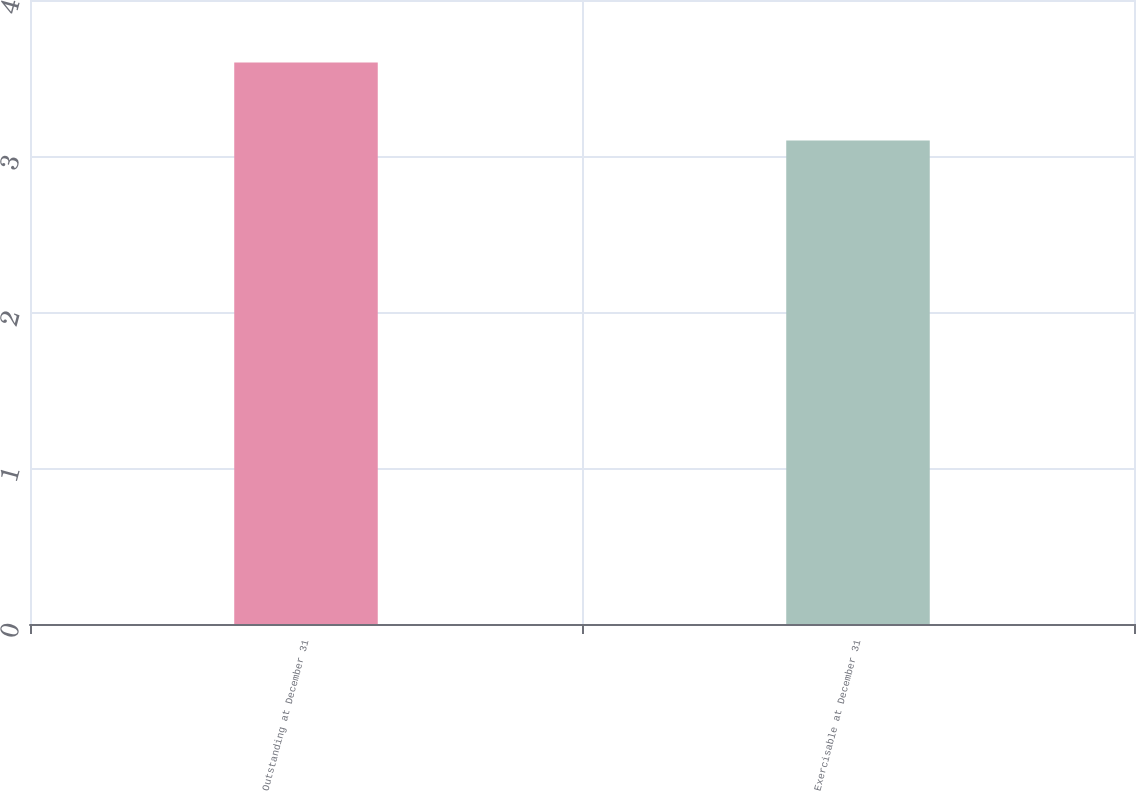Convert chart. <chart><loc_0><loc_0><loc_500><loc_500><bar_chart><fcel>Outstanding at December 31<fcel>Exercisable at December 31<nl><fcel>3.6<fcel>3.1<nl></chart> 